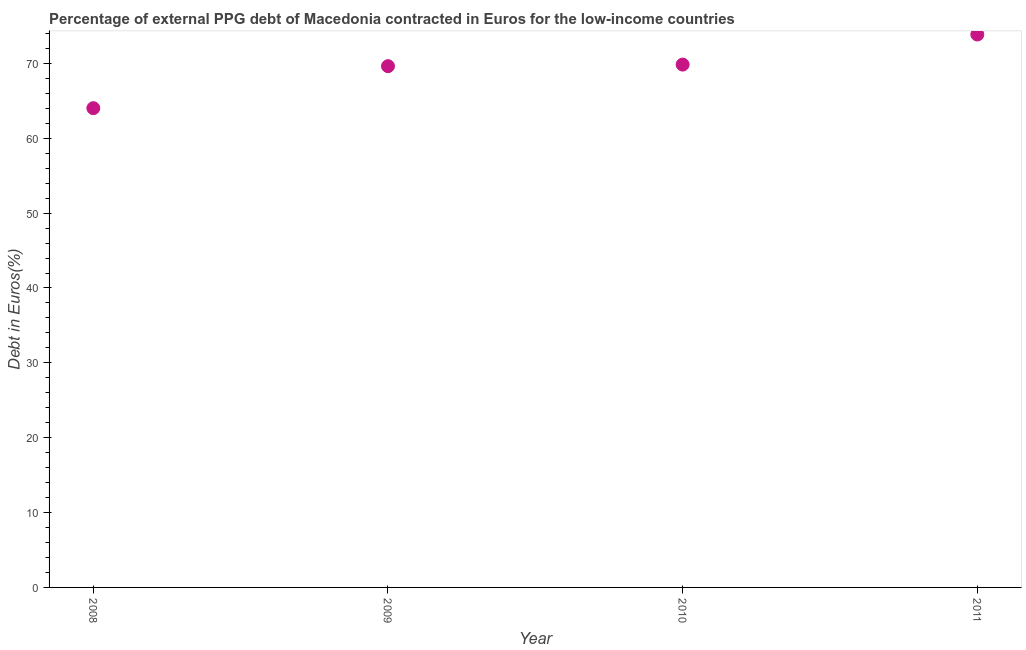What is the currency composition of ppg debt in 2008?
Your response must be concise. 64.02. Across all years, what is the maximum currency composition of ppg debt?
Offer a very short reply. 73.86. Across all years, what is the minimum currency composition of ppg debt?
Keep it short and to the point. 64.02. In which year was the currency composition of ppg debt maximum?
Your answer should be compact. 2011. In which year was the currency composition of ppg debt minimum?
Offer a very short reply. 2008. What is the sum of the currency composition of ppg debt?
Give a very brief answer. 277.36. What is the difference between the currency composition of ppg debt in 2009 and 2011?
Ensure brevity in your answer.  -4.23. What is the average currency composition of ppg debt per year?
Your answer should be very brief. 69.34. What is the median currency composition of ppg debt?
Ensure brevity in your answer.  69.74. In how many years, is the currency composition of ppg debt greater than 58 %?
Make the answer very short. 4. What is the ratio of the currency composition of ppg debt in 2008 to that in 2011?
Ensure brevity in your answer.  0.87. Is the currency composition of ppg debt in 2009 less than that in 2010?
Ensure brevity in your answer.  Yes. What is the difference between the highest and the second highest currency composition of ppg debt?
Provide a succinct answer. 4.02. What is the difference between the highest and the lowest currency composition of ppg debt?
Provide a succinct answer. 9.84. How many years are there in the graph?
Give a very brief answer. 4. Does the graph contain any zero values?
Provide a short and direct response. No. Does the graph contain grids?
Make the answer very short. No. What is the title of the graph?
Give a very brief answer. Percentage of external PPG debt of Macedonia contracted in Euros for the low-income countries. What is the label or title of the X-axis?
Make the answer very short. Year. What is the label or title of the Y-axis?
Your answer should be very brief. Debt in Euros(%). What is the Debt in Euros(%) in 2008?
Your answer should be very brief. 64.02. What is the Debt in Euros(%) in 2009?
Offer a very short reply. 69.63. What is the Debt in Euros(%) in 2010?
Offer a terse response. 69.84. What is the Debt in Euros(%) in 2011?
Ensure brevity in your answer.  73.86. What is the difference between the Debt in Euros(%) in 2008 and 2009?
Keep it short and to the point. -5.61. What is the difference between the Debt in Euros(%) in 2008 and 2010?
Provide a succinct answer. -5.82. What is the difference between the Debt in Euros(%) in 2008 and 2011?
Give a very brief answer. -9.84. What is the difference between the Debt in Euros(%) in 2009 and 2010?
Offer a terse response. -0.21. What is the difference between the Debt in Euros(%) in 2009 and 2011?
Your answer should be very brief. -4.23. What is the difference between the Debt in Euros(%) in 2010 and 2011?
Make the answer very short. -4.02. What is the ratio of the Debt in Euros(%) in 2008 to that in 2009?
Make the answer very short. 0.92. What is the ratio of the Debt in Euros(%) in 2008 to that in 2010?
Offer a terse response. 0.92. What is the ratio of the Debt in Euros(%) in 2008 to that in 2011?
Offer a very short reply. 0.87. What is the ratio of the Debt in Euros(%) in 2009 to that in 2010?
Offer a very short reply. 1. What is the ratio of the Debt in Euros(%) in 2009 to that in 2011?
Make the answer very short. 0.94. What is the ratio of the Debt in Euros(%) in 2010 to that in 2011?
Provide a short and direct response. 0.95. 